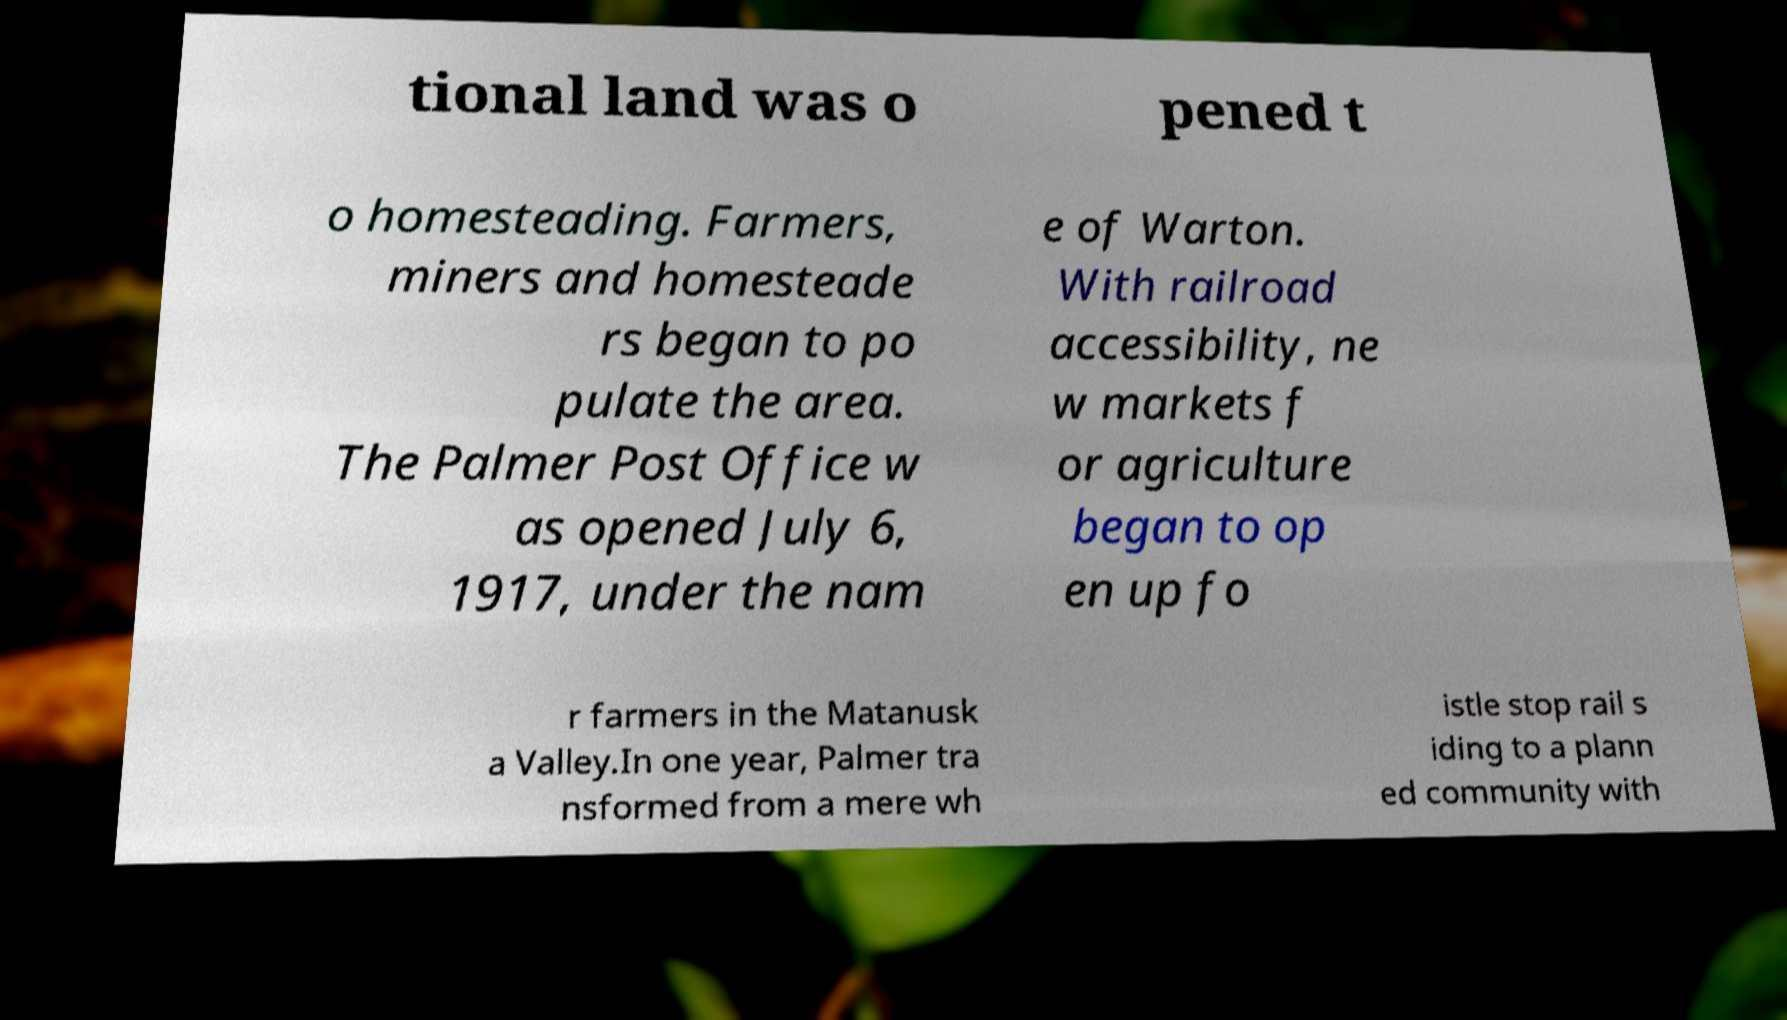Please read and relay the text visible in this image. What does it say? tional land was o pened t o homesteading. Farmers, miners and homesteade rs began to po pulate the area. The Palmer Post Office w as opened July 6, 1917, under the nam e of Warton. With railroad accessibility, ne w markets f or agriculture began to op en up fo r farmers in the Matanusk a Valley.In one year, Palmer tra nsformed from a mere wh istle stop rail s iding to a plann ed community with 